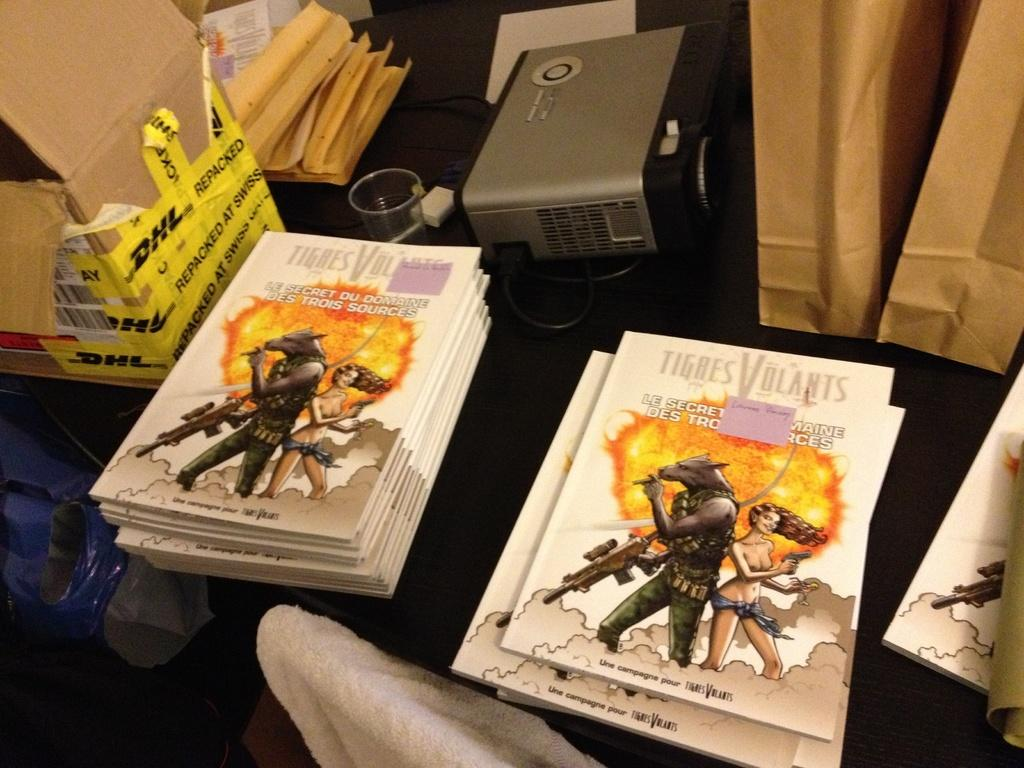Provide a one-sentence caption for the provided image. Several books by Tigres Volants are stacked on top of one another. 